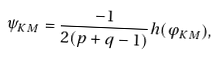<formula> <loc_0><loc_0><loc_500><loc_500>\psi _ { K M } = \frac { - 1 } { 2 ( p + q - 1 ) } h ( \varphi _ { K M } ) ,</formula> 